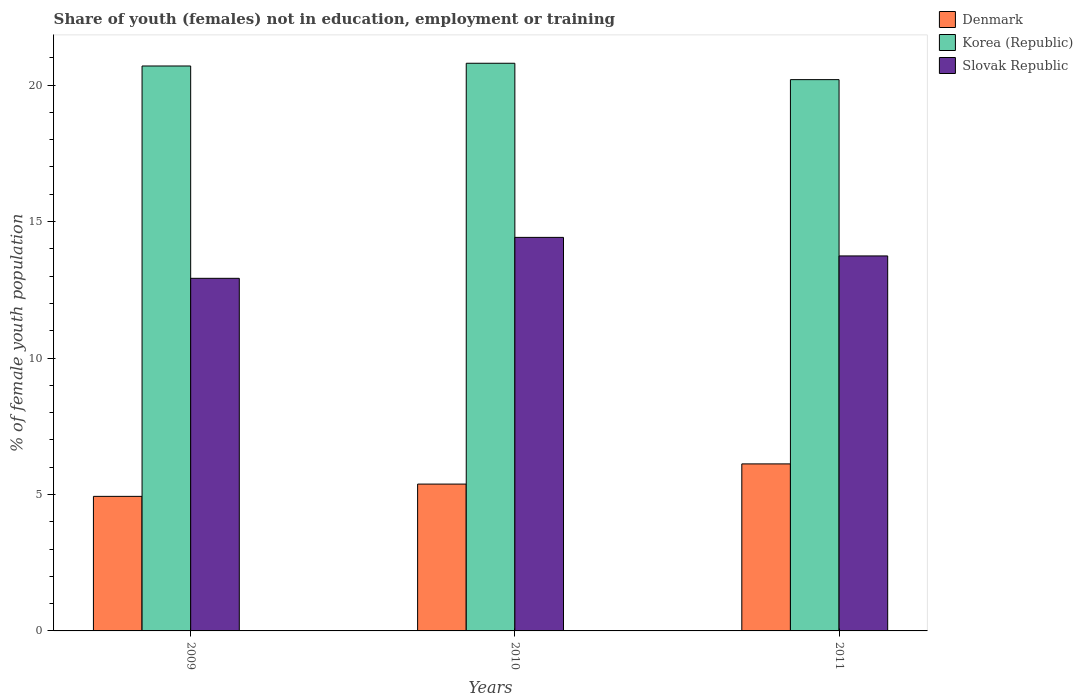Are the number of bars per tick equal to the number of legend labels?
Provide a succinct answer. Yes. How many bars are there on the 2nd tick from the right?
Offer a terse response. 3. What is the percentage of unemployed female population in in Korea (Republic) in 2010?
Your response must be concise. 20.8. Across all years, what is the maximum percentage of unemployed female population in in Korea (Republic)?
Your response must be concise. 20.8. Across all years, what is the minimum percentage of unemployed female population in in Slovak Republic?
Your response must be concise. 12.92. In which year was the percentage of unemployed female population in in Slovak Republic maximum?
Provide a short and direct response. 2010. What is the total percentage of unemployed female population in in Denmark in the graph?
Offer a very short reply. 16.43. What is the difference between the percentage of unemployed female population in in Korea (Republic) in 2011 and the percentage of unemployed female population in in Denmark in 2009?
Keep it short and to the point. 15.27. What is the average percentage of unemployed female population in in Korea (Republic) per year?
Provide a short and direct response. 20.57. In the year 2009, what is the difference between the percentage of unemployed female population in in Korea (Republic) and percentage of unemployed female population in in Slovak Republic?
Offer a terse response. 7.78. What is the ratio of the percentage of unemployed female population in in Slovak Republic in 2009 to that in 2010?
Provide a short and direct response. 0.9. Is the percentage of unemployed female population in in Korea (Republic) in 2010 less than that in 2011?
Provide a succinct answer. No. What is the difference between the highest and the second highest percentage of unemployed female population in in Denmark?
Your response must be concise. 0.74. What is the difference between the highest and the lowest percentage of unemployed female population in in Slovak Republic?
Ensure brevity in your answer.  1.5. What does the 3rd bar from the right in 2009 represents?
Offer a terse response. Denmark. Are all the bars in the graph horizontal?
Make the answer very short. No. How many years are there in the graph?
Keep it short and to the point. 3. Are the values on the major ticks of Y-axis written in scientific E-notation?
Provide a short and direct response. No. Does the graph contain grids?
Your answer should be compact. No. What is the title of the graph?
Provide a succinct answer. Share of youth (females) not in education, employment or training. Does "South Sudan" appear as one of the legend labels in the graph?
Your answer should be compact. No. What is the label or title of the X-axis?
Ensure brevity in your answer.  Years. What is the label or title of the Y-axis?
Provide a succinct answer. % of female youth population. What is the % of female youth population of Denmark in 2009?
Make the answer very short. 4.93. What is the % of female youth population in Korea (Republic) in 2009?
Offer a terse response. 20.7. What is the % of female youth population in Slovak Republic in 2009?
Make the answer very short. 12.92. What is the % of female youth population in Denmark in 2010?
Make the answer very short. 5.38. What is the % of female youth population in Korea (Republic) in 2010?
Your response must be concise. 20.8. What is the % of female youth population in Slovak Republic in 2010?
Your response must be concise. 14.42. What is the % of female youth population of Denmark in 2011?
Ensure brevity in your answer.  6.12. What is the % of female youth population of Korea (Republic) in 2011?
Provide a short and direct response. 20.2. What is the % of female youth population of Slovak Republic in 2011?
Your answer should be compact. 13.74. Across all years, what is the maximum % of female youth population in Denmark?
Keep it short and to the point. 6.12. Across all years, what is the maximum % of female youth population of Korea (Republic)?
Keep it short and to the point. 20.8. Across all years, what is the maximum % of female youth population in Slovak Republic?
Offer a very short reply. 14.42. Across all years, what is the minimum % of female youth population of Denmark?
Give a very brief answer. 4.93. Across all years, what is the minimum % of female youth population of Korea (Republic)?
Provide a succinct answer. 20.2. Across all years, what is the minimum % of female youth population in Slovak Republic?
Make the answer very short. 12.92. What is the total % of female youth population in Denmark in the graph?
Provide a short and direct response. 16.43. What is the total % of female youth population in Korea (Republic) in the graph?
Your answer should be very brief. 61.7. What is the total % of female youth population of Slovak Republic in the graph?
Your answer should be very brief. 41.08. What is the difference between the % of female youth population in Denmark in 2009 and that in 2010?
Your response must be concise. -0.45. What is the difference between the % of female youth population of Korea (Republic) in 2009 and that in 2010?
Make the answer very short. -0.1. What is the difference between the % of female youth population of Slovak Republic in 2009 and that in 2010?
Ensure brevity in your answer.  -1.5. What is the difference between the % of female youth population of Denmark in 2009 and that in 2011?
Offer a terse response. -1.19. What is the difference between the % of female youth population of Korea (Republic) in 2009 and that in 2011?
Make the answer very short. 0.5. What is the difference between the % of female youth population of Slovak Republic in 2009 and that in 2011?
Provide a succinct answer. -0.82. What is the difference between the % of female youth population in Denmark in 2010 and that in 2011?
Ensure brevity in your answer.  -0.74. What is the difference between the % of female youth population of Slovak Republic in 2010 and that in 2011?
Give a very brief answer. 0.68. What is the difference between the % of female youth population of Denmark in 2009 and the % of female youth population of Korea (Republic) in 2010?
Offer a very short reply. -15.87. What is the difference between the % of female youth population in Denmark in 2009 and the % of female youth population in Slovak Republic in 2010?
Make the answer very short. -9.49. What is the difference between the % of female youth population in Korea (Republic) in 2009 and the % of female youth population in Slovak Republic in 2010?
Your response must be concise. 6.28. What is the difference between the % of female youth population in Denmark in 2009 and the % of female youth population in Korea (Republic) in 2011?
Your answer should be compact. -15.27. What is the difference between the % of female youth population of Denmark in 2009 and the % of female youth population of Slovak Republic in 2011?
Your answer should be compact. -8.81. What is the difference between the % of female youth population of Korea (Republic) in 2009 and the % of female youth population of Slovak Republic in 2011?
Make the answer very short. 6.96. What is the difference between the % of female youth population of Denmark in 2010 and the % of female youth population of Korea (Republic) in 2011?
Your response must be concise. -14.82. What is the difference between the % of female youth population in Denmark in 2010 and the % of female youth population in Slovak Republic in 2011?
Make the answer very short. -8.36. What is the difference between the % of female youth population in Korea (Republic) in 2010 and the % of female youth population in Slovak Republic in 2011?
Give a very brief answer. 7.06. What is the average % of female youth population in Denmark per year?
Keep it short and to the point. 5.48. What is the average % of female youth population of Korea (Republic) per year?
Offer a terse response. 20.57. What is the average % of female youth population in Slovak Republic per year?
Keep it short and to the point. 13.69. In the year 2009, what is the difference between the % of female youth population in Denmark and % of female youth population in Korea (Republic)?
Your answer should be compact. -15.77. In the year 2009, what is the difference between the % of female youth population in Denmark and % of female youth population in Slovak Republic?
Provide a short and direct response. -7.99. In the year 2009, what is the difference between the % of female youth population in Korea (Republic) and % of female youth population in Slovak Republic?
Your answer should be compact. 7.78. In the year 2010, what is the difference between the % of female youth population of Denmark and % of female youth population of Korea (Republic)?
Provide a short and direct response. -15.42. In the year 2010, what is the difference between the % of female youth population of Denmark and % of female youth population of Slovak Republic?
Provide a succinct answer. -9.04. In the year 2010, what is the difference between the % of female youth population in Korea (Republic) and % of female youth population in Slovak Republic?
Make the answer very short. 6.38. In the year 2011, what is the difference between the % of female youth population of Denmark and % of female youth population of Korea (Republic)?
Offer a very short reply. -14.08. In the year 2011, what is the difference between the % of female youth population in Denmark and % of female youth population in Slovak Republic?
Provide a succinct answer. -7.62. In the year 2011, what is the difference between the % of female youth population in Korea (Republic) and % of female youth population in Slovak Republic?
Give a very brief answer. 6.46. What is the ratio of the % of female youth population in Denmark in 2009 to that in 2010?
Offer a very short reply. 0.92. What is the ratio of the % of female youth population in Korea (Republic) in 2009 to that in 2010?
Provide a succinct answer. 1. What is the ratio of the % of female youth population in Slovak Republic in 2009 to that in 2010?
Your answer should be compact. 0.9. What is the ratio of the % of female youth population of Denmark in 2009 to that in 2011?
Make the answer very short. 0.81. What is the ratio of the % of female youth population of Korea (Republic) in 2009 to that in 2011?
Keep it short and to the point. 1.02. What is the ratio of the % of female youth population in Slovak Republic in 2009 to that in 2011?
Your answer should be very brief. 0.94. What is the ratio of the % of female youth population in Denmark in 2010 to that in 2011?
Your answer should be very brief. 0.88. What is the ratio of the % of female youth population of Korea (Republic) in 2010 to that in 2011?
Offer a very short reply. 1.03. What is the ratio of the % of female youth population in Slovak Republic in 2010 to that in 2011?
Your answer should be very brief. 1.05. What is the difference between the highest and the second highest % of female youth population in Denmark?
Provide a short and direct response. 0.74. What is the difference between the highest and the second highest % of female youth population of Slovak Republic?
Keep it short and to the point. 0.68. What is the difference between the highest and the lowest % of female youth population of Denmark?
Provide a succinct answer. 1.19. What is the difference between the highest and the lowest % of female youth population in Korea (Republic)?
Offer a very short reply. 0.6. 